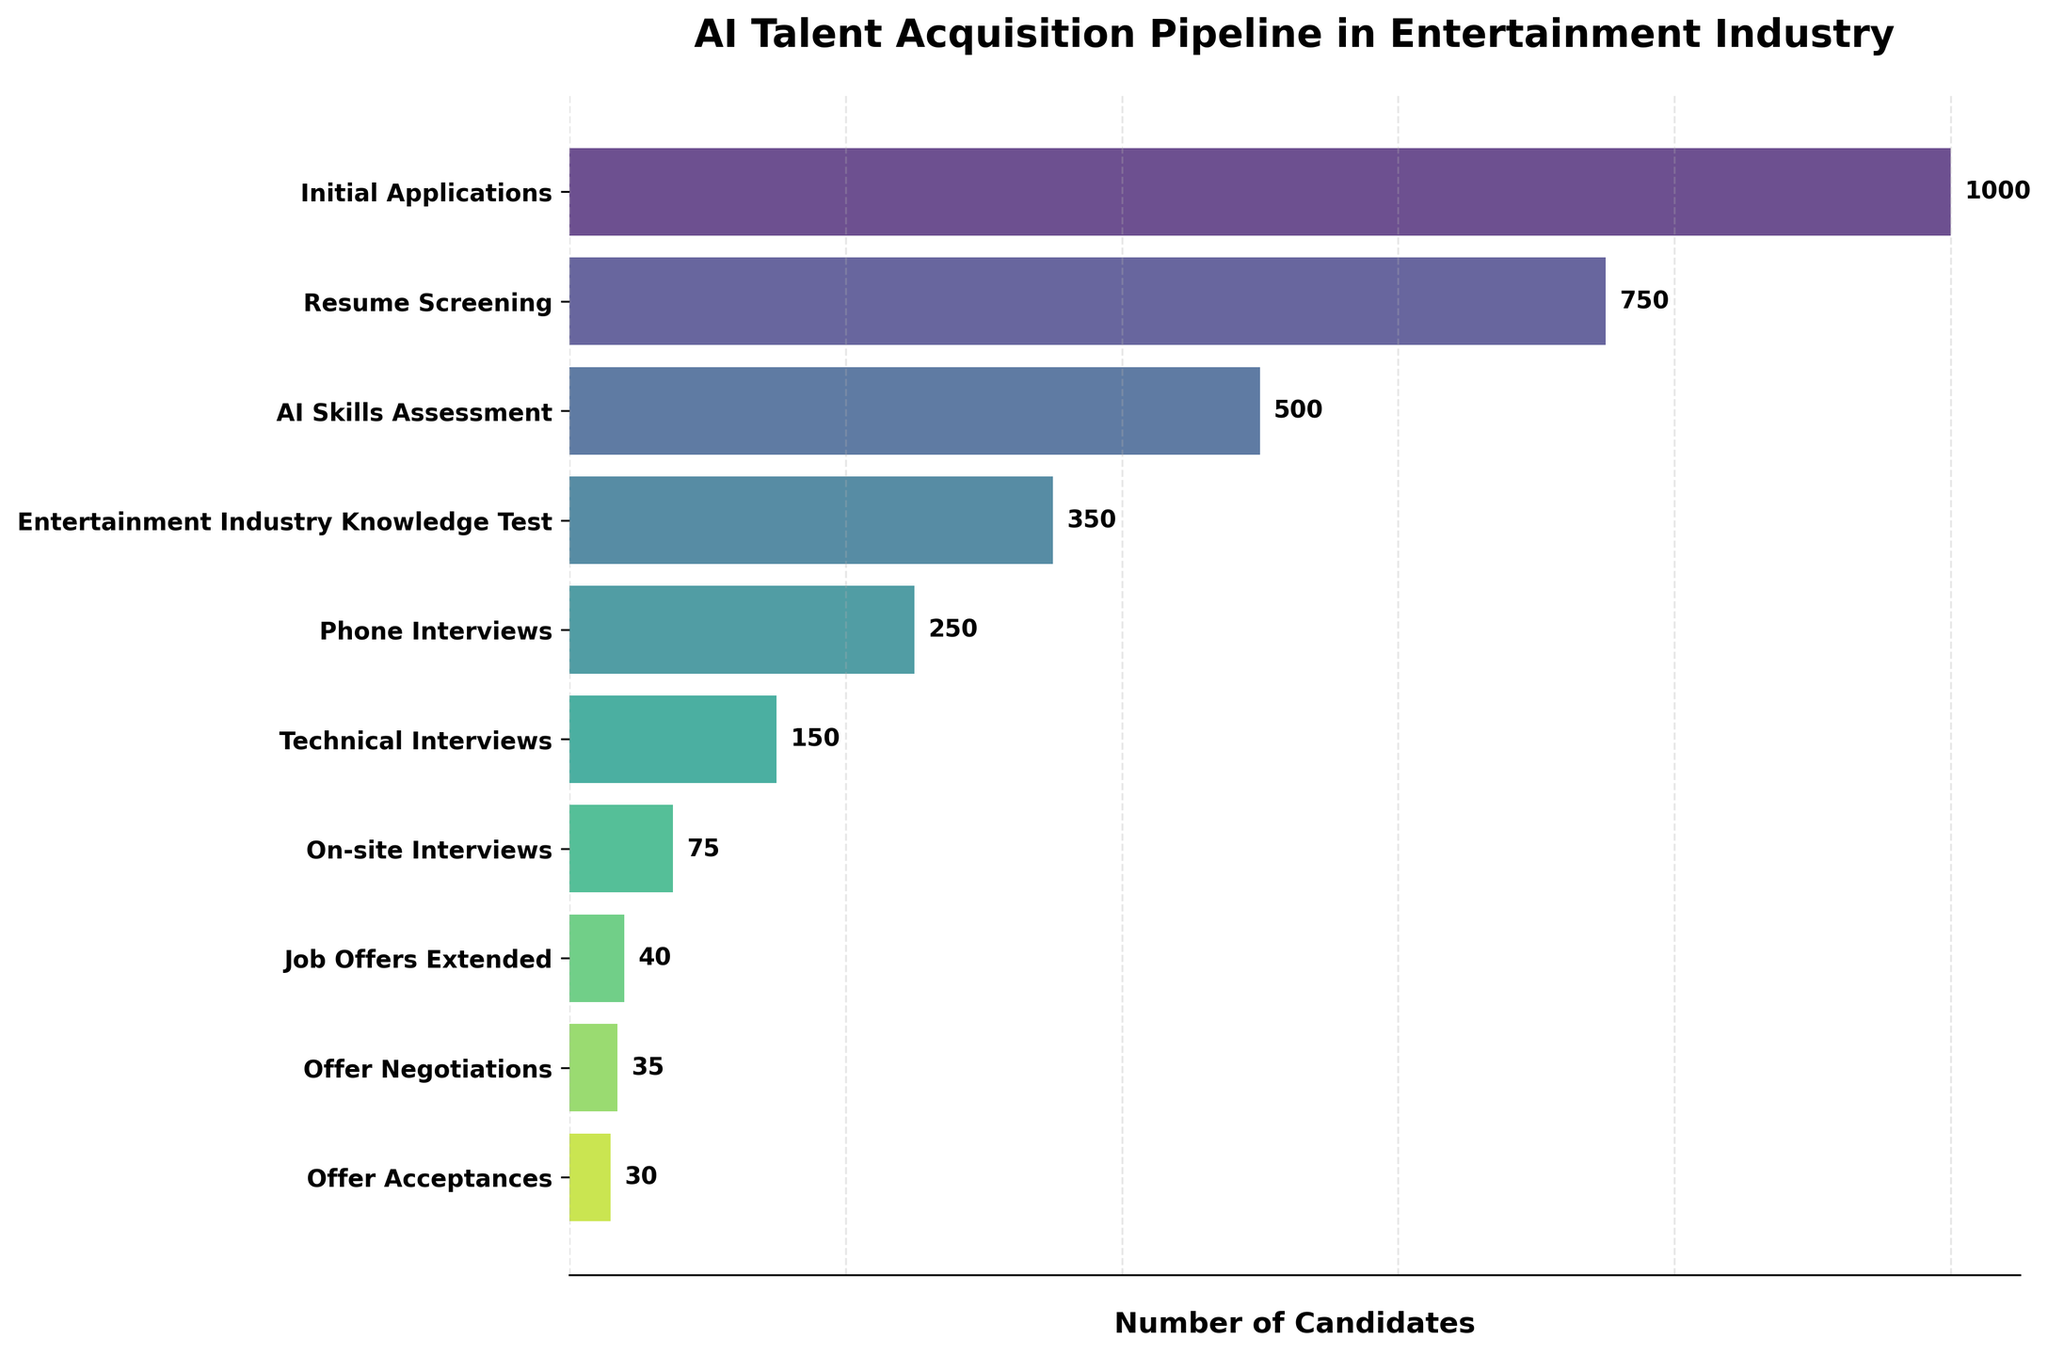What is the total number of candidates who applied initially? Summation of candidates from all stages shows 1000 candidates in the "Initial Applications" stage.
Answer: 1000 How many candidates moved from the "Phone Interviews" stage to the "Technical Interviews" stage? The number of candidates in the "Technical Interviews" stage subtracted from the "Phone Interviews" stage gives 250 - 150 = 100.
Answer: 100 What is the title of the chart? The title is located at the top center of the plot and reads "AI Talent Acquisition Pipeline in Entertainment Industry".
Answer: AI Talent Acquisition Pipeline in Entertainment Industry What percentage of candidates proceeded from "Tech Interviews" to "On-site Interviews"? Divide the number of candidates in "On-site Interviews" by "Technical Interviews" and multiply by 100, yielding (75 / 150) * 100 = 50%.
Answer: 50% Which two stages have the greatest difference in the number of candidates? Comparing differences between stages, "Technical Interviews" (150 candidates) and "On-site Interviews" (75 candidates) have the greatest difference of 75.
Answer: Technical Interviews and On-site Interviews What is the total number of stages displayed in the chart? Counting from the first to the last stage in the y-axis provides a total of 10 stages.
Answer: 10 What color palette is used for the stages? The stages in the funnel chart are colored using a gradient from the Viridis color map, varying from shades of green to purple.
Answer: Viridis How many more candidates were there in the "AI Skills Assessment" stage compared to the "Entertainment Industry Knowledge Test" stage? Subtracting candidates from the "Entertainment Industry Knowledge Test" stage from the "AI Skills Assessment" stage calculates 500 - 350 = 150.
Answer: 150 Which stage had the fewest candidates? The "Offer Acceptances" stage has the fewest candidates recorded at 30, which is evident from the farthest right bar on the plot.
Answer: Offer Acceptances What is the ratio of candidates moving from "Job Offers Extended" to "Offer Acceptances"? Dividing candidates in "Offer Acceptances" (30) by "Job Offers Extended" (40) yields 30/40 = 0.75.
Answer: 0.75 